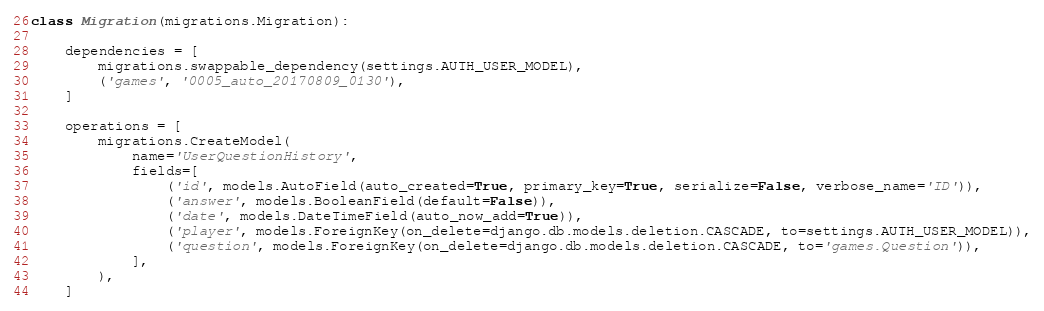<code> <loc_0><loc_0><loc_500><loc_500><_Python_>
class Migration(migrations.Migration):

    dependencies = [
        migrations.swappable_dependency(settings.AUTH_USER_MODEL),
        ('games', '0005_auto_20170809_0130'),
    ]

    operations = [
        migrations.CreateModel(
            name='UserQuestionHistory',
            fields=[
                ('id', models.AutoField(auto_created=True, primary_key=True, serialize=False, verbose_name='ID')),
                ('answer', models.BooleanField(default=False)),
                ('date', models.DateTimeField(auto_now_add=True)),
                ('player', models.ForeignKey(on_delete=django.db.models.deletion.CASCADE, to=settings.AUTH_USER_MODEL)),
                ('question', models.ForeignKey(on_delete=django.db.models.deletion.CASCADE, to='games.Question')),
            ],
        ),
    ]
</code> 